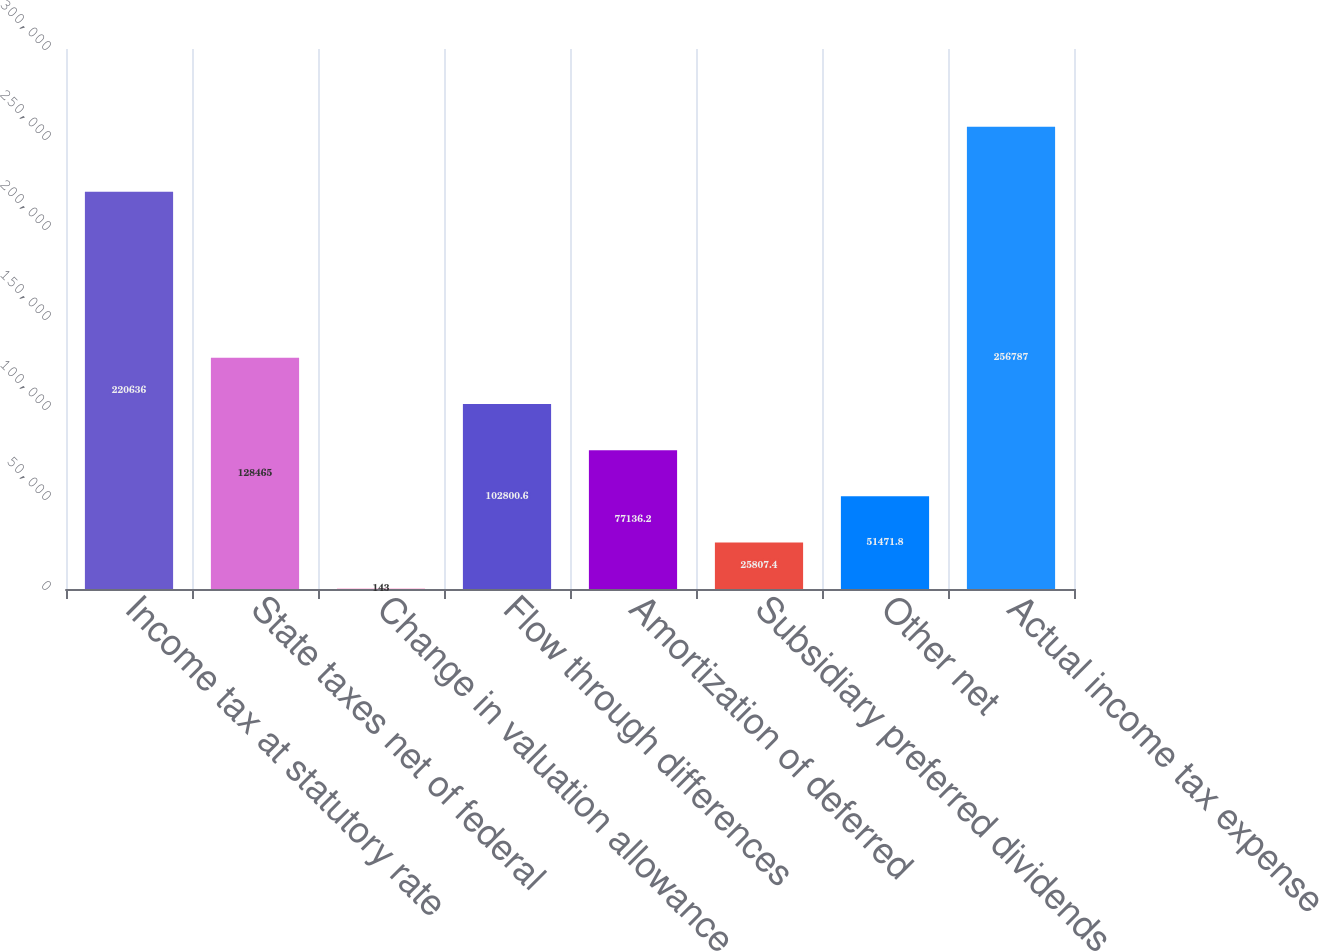<chart> <loc_0><loc_0><loc_500><loc_500><bar_chart><fcel>Income tax at statutory rate<fcel>State taxes net of federal<fcel>Change in valuation allowance<fcel>Flow through differences<fcel>Amortization of deferred<fcel>Subsidiary preferred dividends<fcel>Other net<fcel>Actual income tax expense<nl><fcel>220636<fcel>128465<fcel>143<fcel>102801<fcel>77136.2<fcel>25807.4<fcel>51471.8<fcel>256787<nl></chart> 